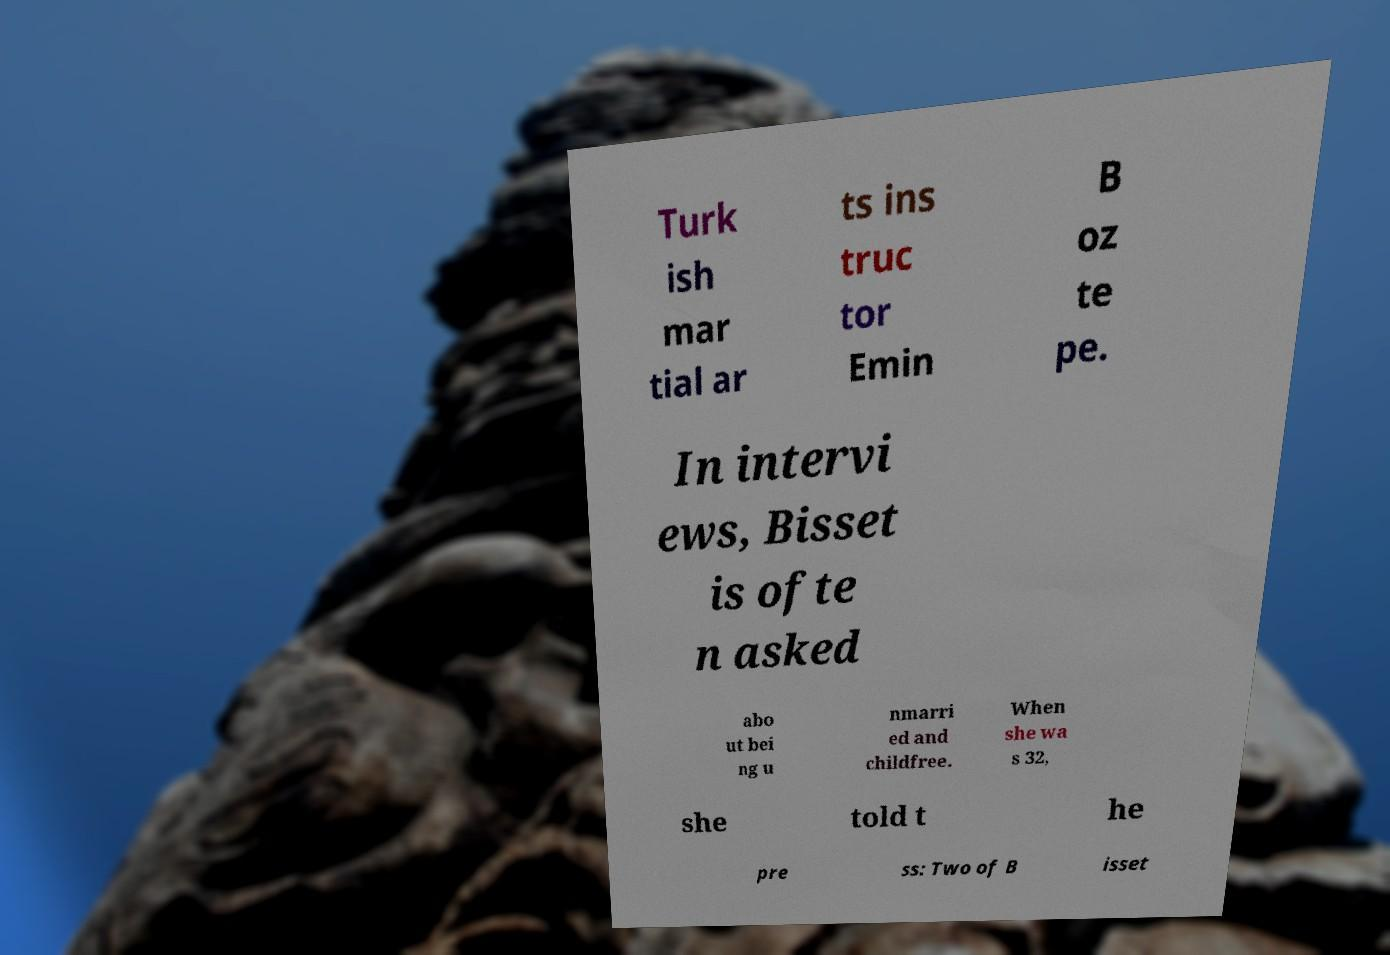Could you extract and type out the text from this image? Turk ish mar tial ar ts ins truc tor Emin B oz te pe. In intervi ews, Bisset is ofte n asked abo ut bei ng u nmarri ed and childfree. When she wa s 32, she told t he pre ss: Two of B isset 